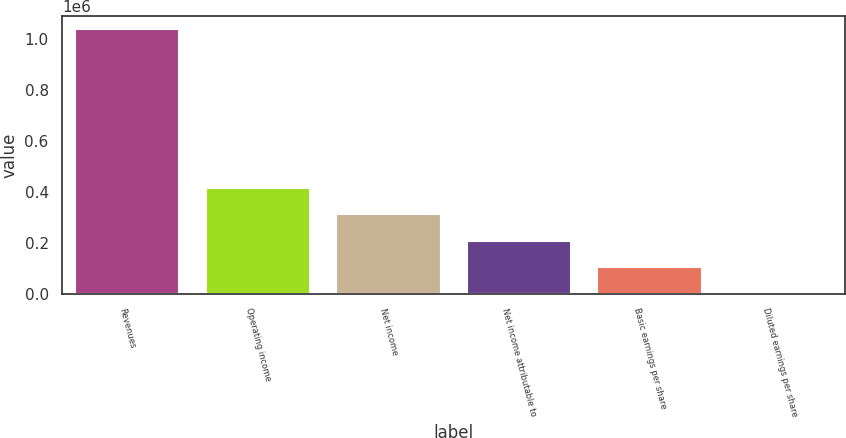<chart> <loc_0><loc_0><loc_500><loc_500><bar_chart><fcel>Revenues<fcel>Operating income<fcel>Net income<fcel>Net income attributable to<fcel>Basic earnings per share<fcel>Diluted earnings per share<nl><fcel>1.03891e+06<fcel>415563<fcel>311673<fcel>207782<fcel>103891<fcel>0.71<nl></chart> 